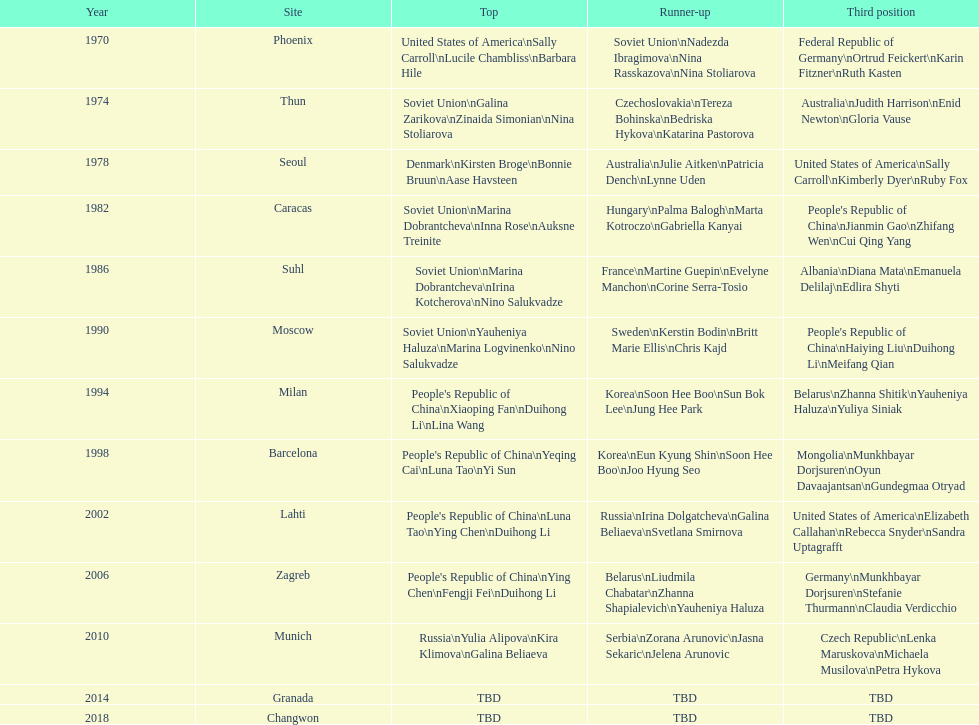What is the first place listed in this chart? Phoenix. 